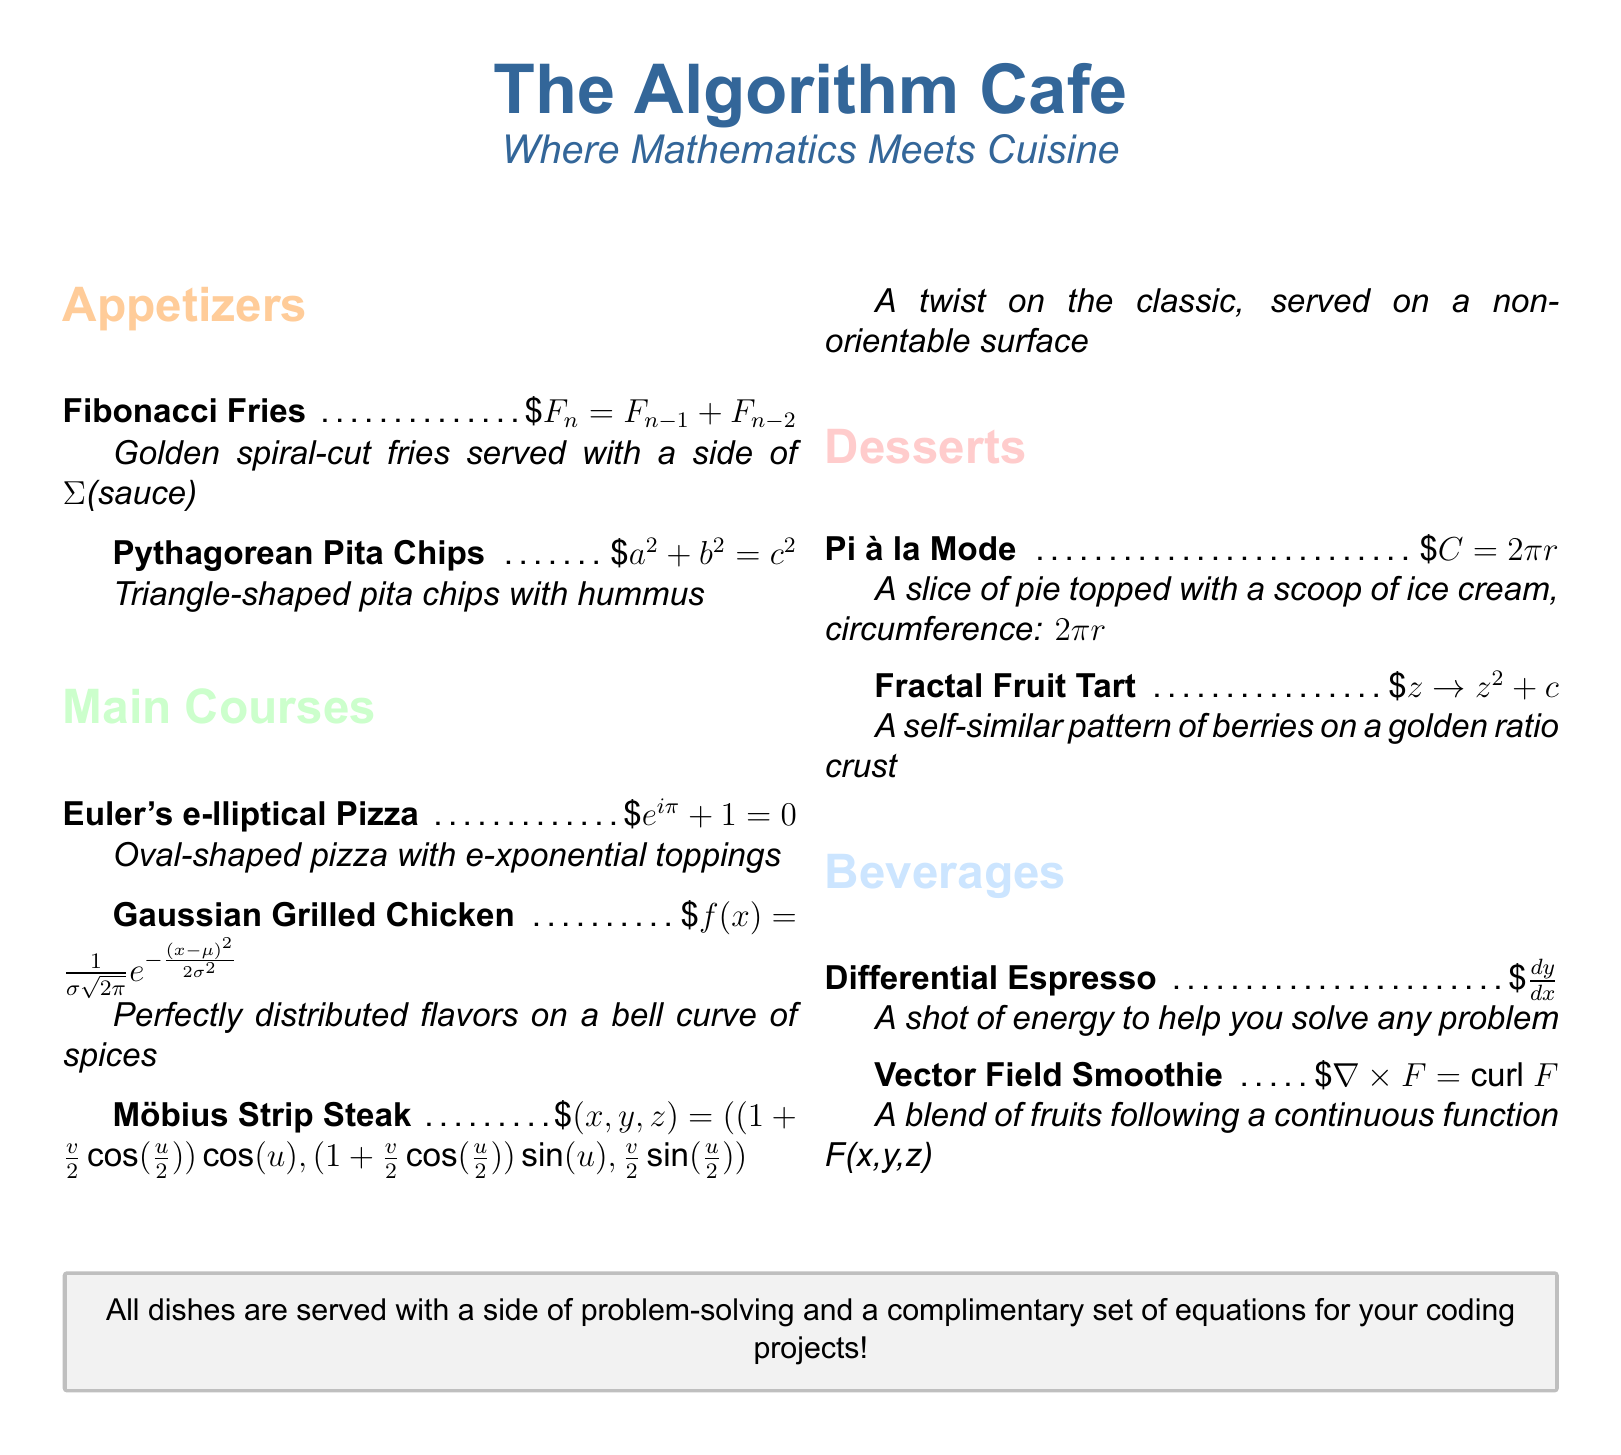What is the name of the cafe? The name of the cafe is prominently displayed at the top of the menu.
Answer: The Algorithm Cafe How many sections are there in the menu? The menu is divided into four sections: Appetizers, Main Courses, Desserts, and Beverages.
Answer: Four What is the price of the Pi à la Mode? The price is listed next to the item description in the dessert section.
Answer: $8 What mathematical concept is represented by Fibonacci Fries? The dish is represented by the Fibonacci sequence, indicated by the equation.
Answer: Fibonacci sequence What type of chips are served with hummus? The menu specifies the shape of the chips served in the appetizer section.
Answer: Triangle-shaped What is the special ingredient that makes the Vector Field Smoothie unique? The smoothie is inspired by a mathematical concept describing a blend of fruits.
Answer: Continuous function Which dessert features a self-similar pattern? The item in the dessert section showing a self-similar design.
Answer: Fractal Fruit Tart What equation is associated with the Gaussian Grilled Chicken? The menu provides the specific mathematical formula associated with this dish.
Answer: f(x) = 1/σ√2π e^−(x−μ)²/2σ² What side is offered with all dishes? The menu mentions something that accompanies every dish.
Answer: A side of problem-solving 